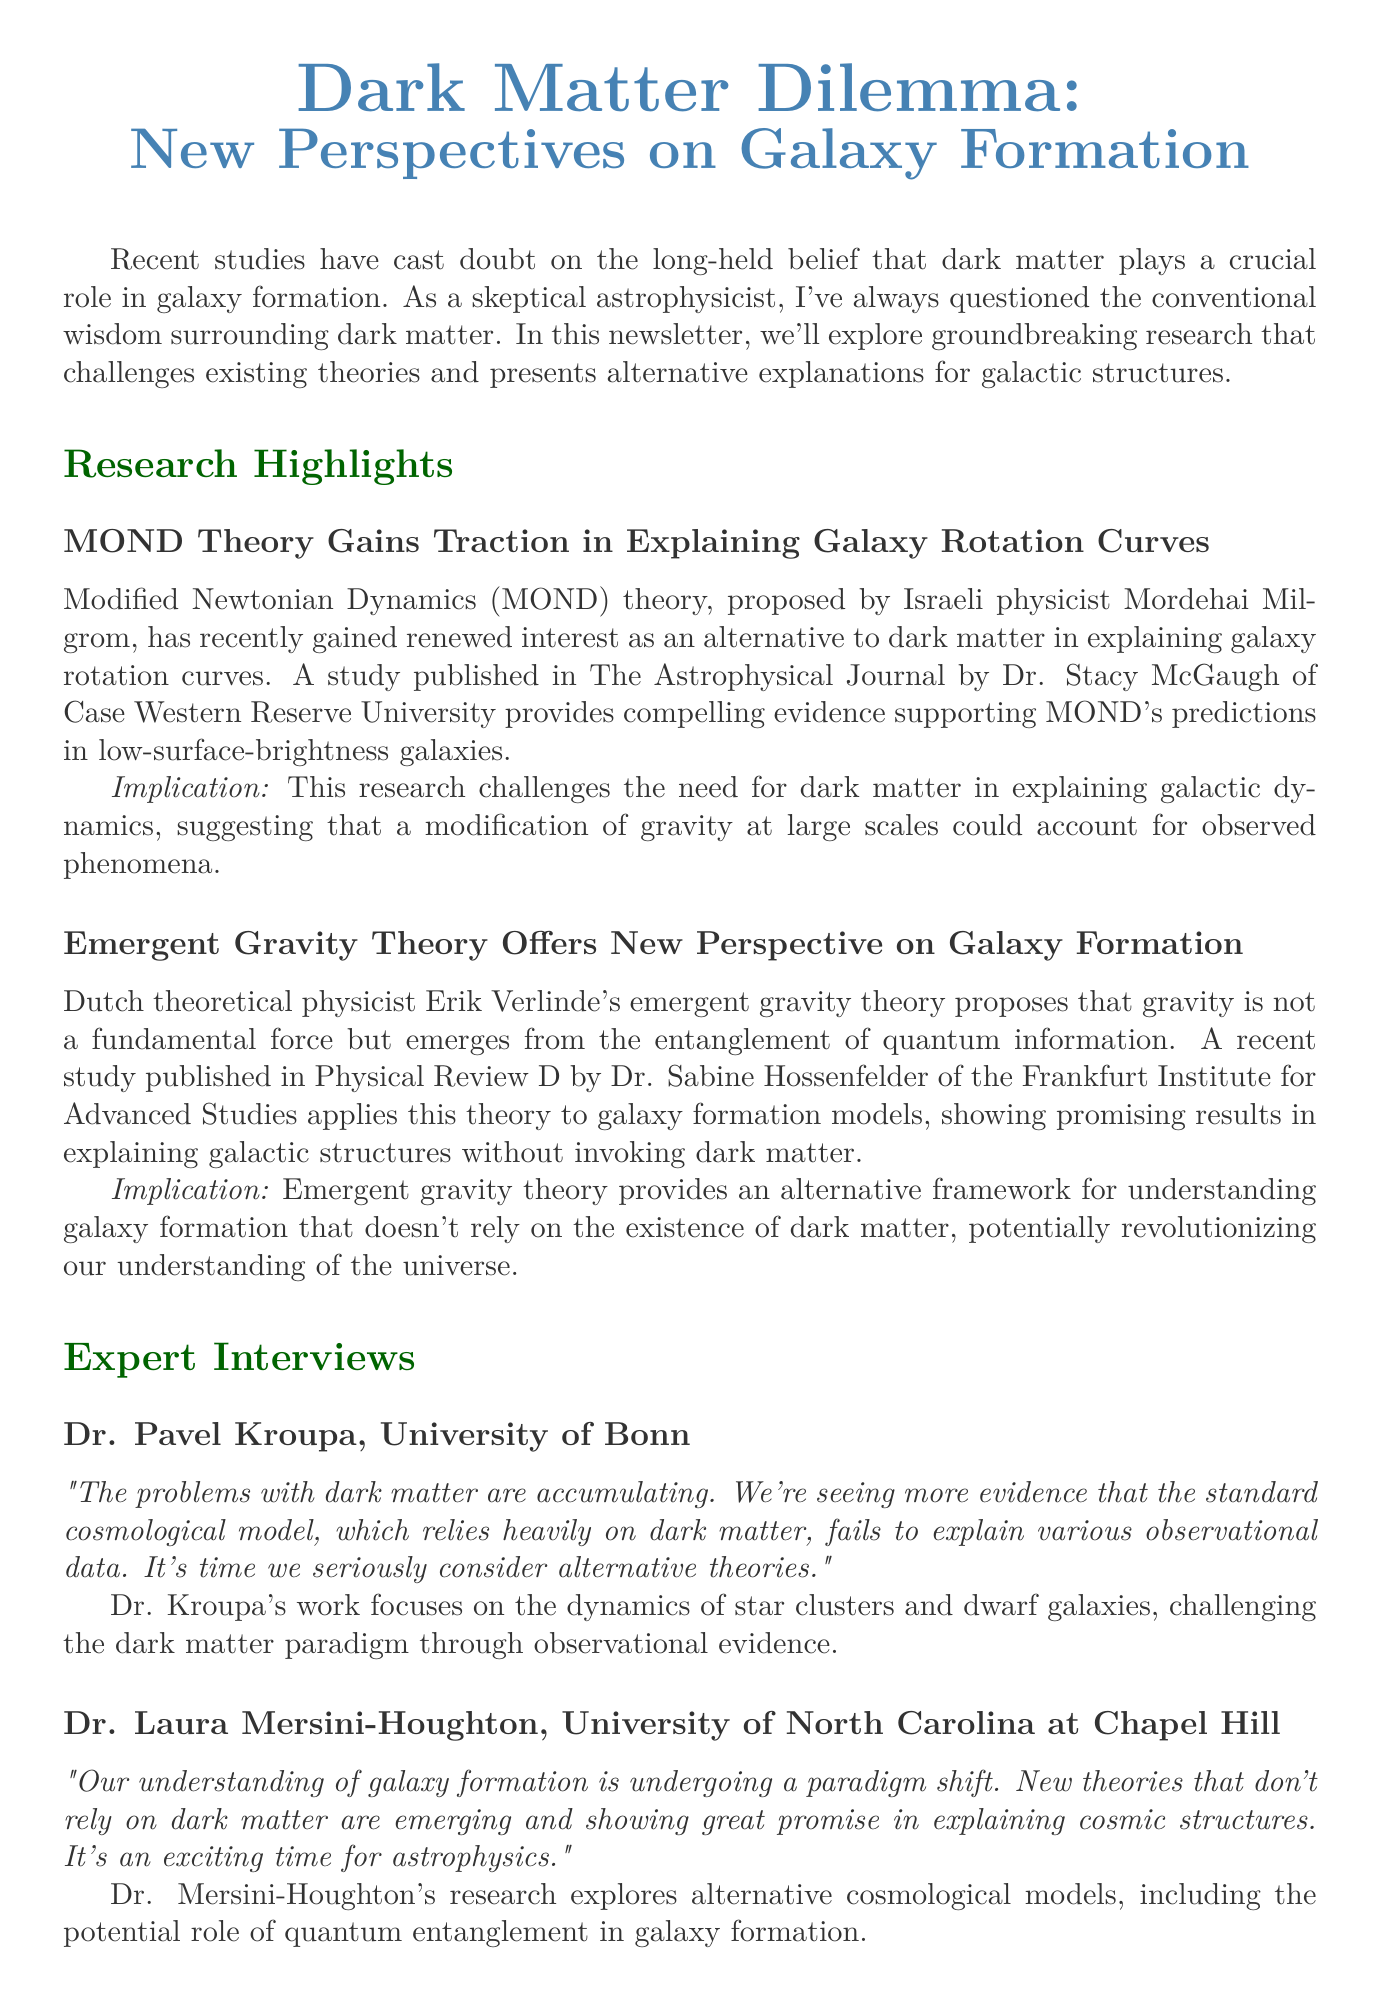what is the title of the newsletter? The title of the newsletter is presented at the beginning of the document.
Answer: Dark Matter Dilemma: New Perspectives on Galaxy Formation who published the study supporting MOND theory? The newsletter indicates the researcher who conducted the study related to MOND theory and their affiliation.
Answer: Dr. Stacy McGaugh of Case Western Reserve University what is the date of the upcoming conference? The date of the upcoming conference is explicitly stated in the conference section of the document.
Answer: October 15-18, 2023 which theory proposes that gravity emerges from quantum information entanglement? The newsletter highlights a theory related to emergent gravity and its proposer.
Answer: Emergent gravity theory how does Dr. Pavel Kroupa perceive the standard cosmological model? The quote from Dr. Kroupa summarizes his view on the standard cosmological model and dark matter.
Answer: Fails to explain various observational data what is the key implication of emergent gravity theory on galaxy formation? The document outlines the implication of emergent gravity theory concerning dark matter.
Answer: Doesn't rely on the existence of dark matter how many research highlights are presented in the newsletter? The document lists the research highlights that challenge dark matter theories.
Answer: Two who is the affiliated institution of Dr. Laura Mersini-Houghton? The newsletter provides Dr. Mersini-Houghton's affiliation in the expert interview section.
Answer: University of North Carolina at Chapel Hill 